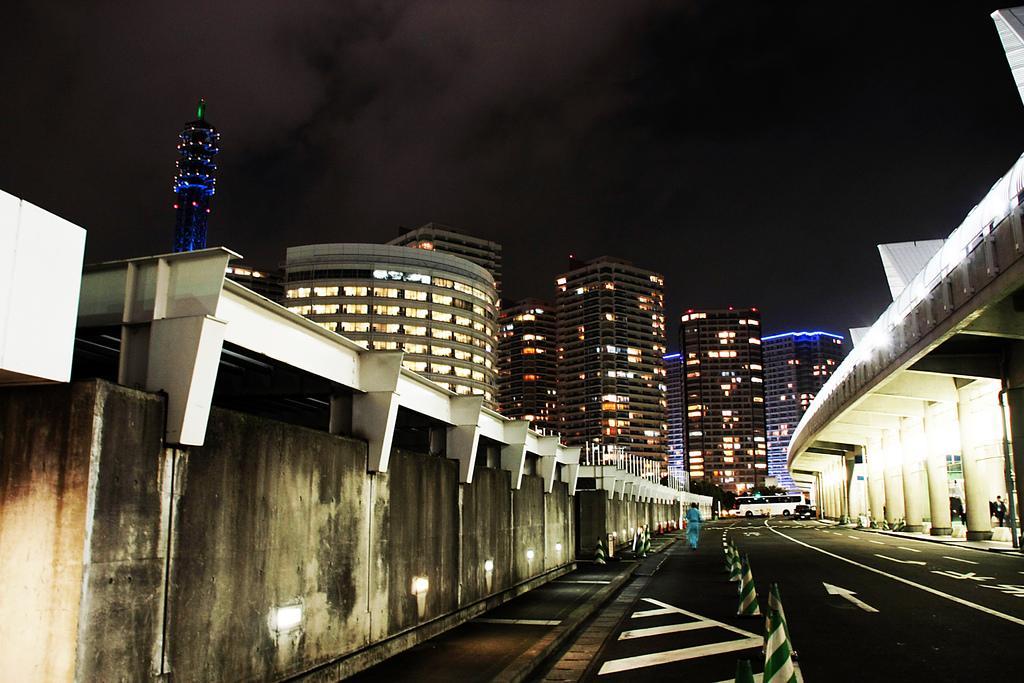How would you summarize this image in a sentence or two? In this image, we can see some buildings. There is a bridge on the right side of the image. There is a person and bus in the middle of the image. There is a wall beside the road. There are divider cones at the bottom of the image. At the top of the image, we can see the sky. 